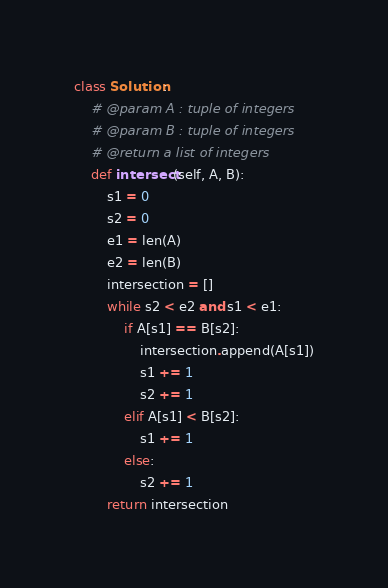Convert code to text. <code><loc_0><loc_0><loc_500><loc_500><_Python_>class Solution:
    # @param A : tuple of integers
    # @param B : tuple of integers
    # @return a list of integers
    def intersect(self, A, B):
        s1 = 0
        s2 = 0
        e1 = len(A)
        e2 = len(B)
        intersection = []
        while s2 < e2 and s1 < e1:
            if A[s1] == B[s2]:
                intersection.append(A[s1])
                s1 += 1
                s2 += 1
            elif A[s1] < B[s2]:
                s1 += 1
            else:
                s2 += 1
        return intersection
</code> 